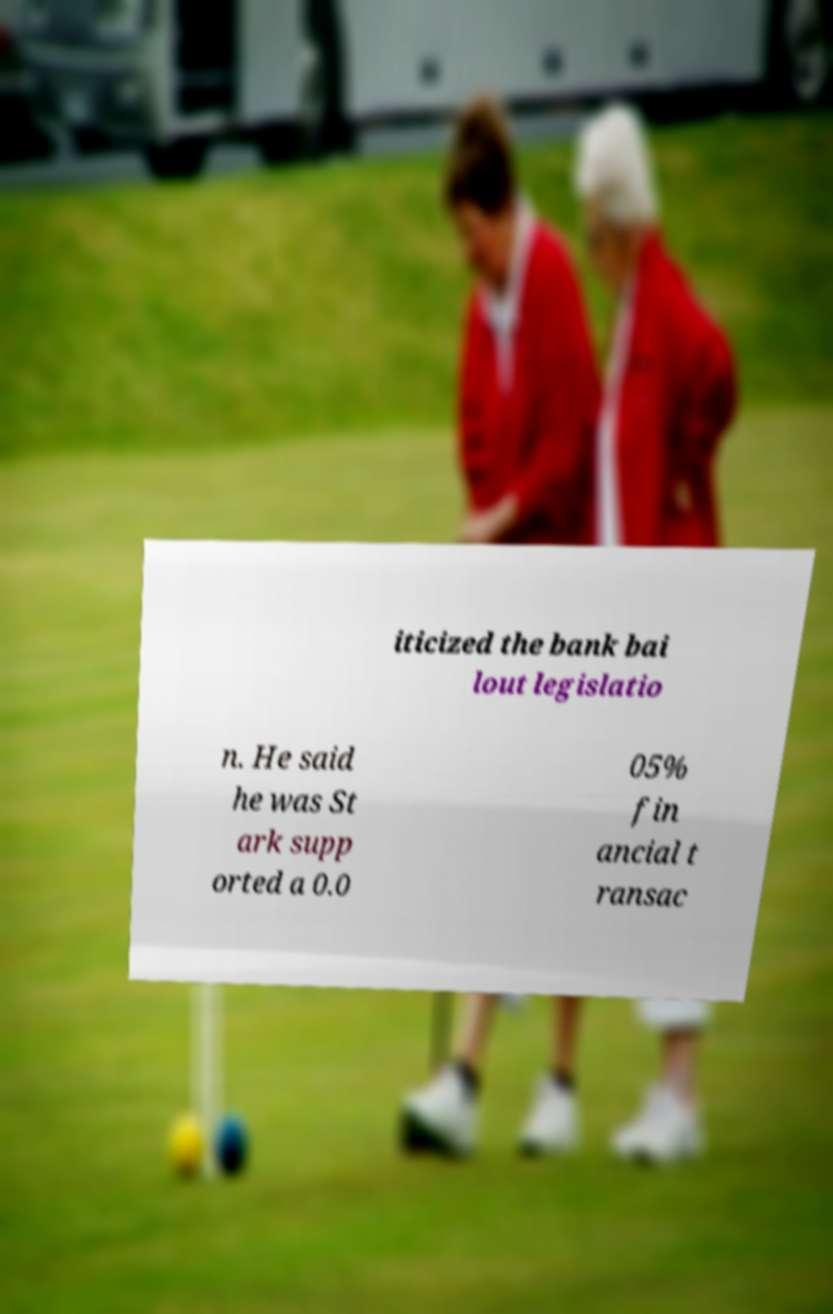Please identify and transcribe the text found in this image. iticized the bank bai lout legislatio n. He said he was St ark supp orted a 0.0 05% fin ancial t ransac 